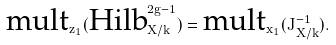Convert formula to latex. <formula><loc_0><loc_0><loc_500><loc_500>\text {mult} _ { z _ { 1 } } ( \text {Hilb} _ { X / k } ^ { 2 g - 1 } ) = \text {mult} _ { x _ { 1 } } ( \bar { J } _ { X / k } ^ { - 1 } ) .</formula> 